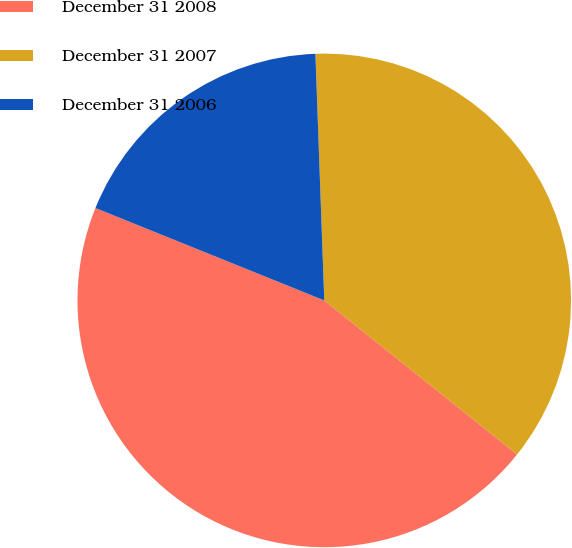Convert chart to OTSL. <chart><loc_0><loc_0><loc_500><loc_500><pie_chart><fcel>December 31 2008<fcel>December 31 2007<fcel>December 31 2006<nl><fcel>45.38%<fcel>36.3%<fcel>18.32%<nl></chart> 